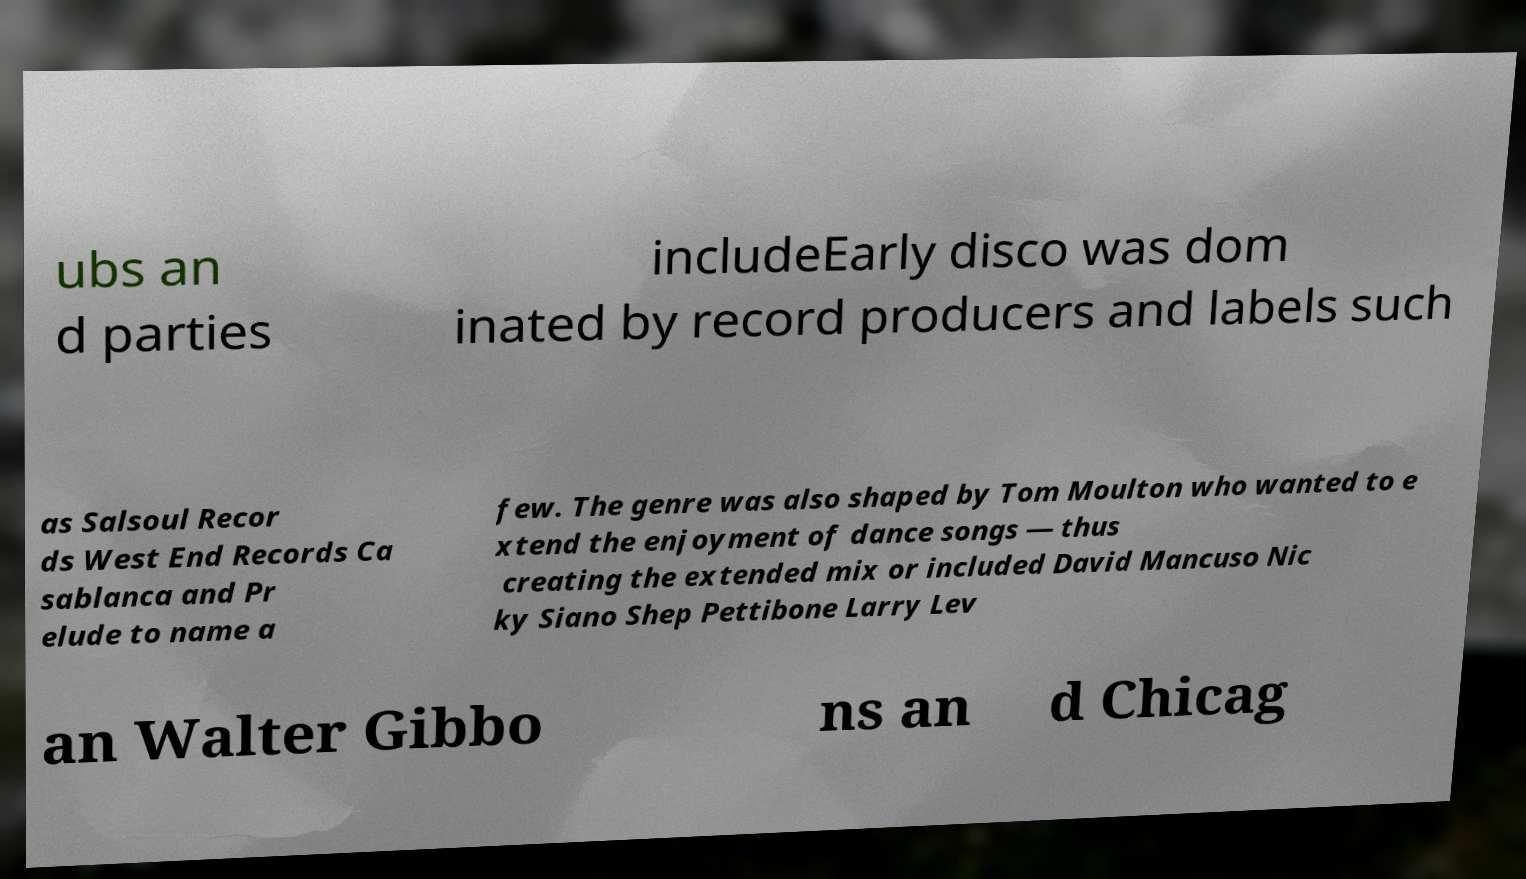For documentation purposes, I need the text within this image transcribed. Could you provide that? ubs an d parties includeEarly disco was dom inated by record producers and labels such as Salsoul Recor ds West End Records Ca sablanca and Pr elude to name a few. The genre was also shaped by Tom Moulton who wanted to e xtend the enjoyment of dance songs — thus creating the extended mix or included David Mancuso Nic ky Siano Shep Pettibone Larry Lev an Walter Gibbo ns an d Chicag 